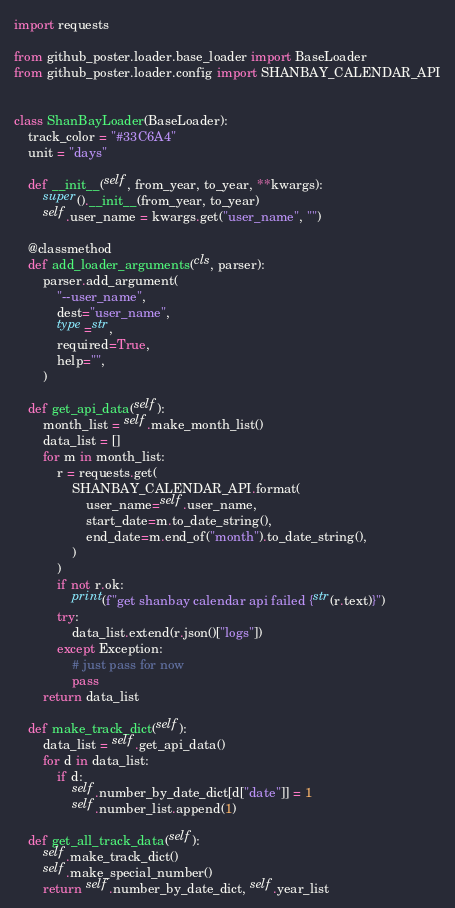<code> <loc_0><loc_0><loc_500><loc_500><_Python_>import requests

from github_poster.loader.base_loader import BaseLoader
from github_poster.loader.config import SHANBAY_CALENDAR_API


class ShanBayLoader(BaseLoader):
    track_color = "#33C6A4"
    unit = "days"

    def __init__(self, from_year, to_year, **kwargs):
        super().__init__(from_year, to_year)
        self.user_name = kwargs.get("user_name", "")

    @classmethod
    def add_loader_arguments(cls, parser):
        parser.add_argument(
            "--user_name",
            dest="user_name",
            type=str,
            required=True,
            help="",
        )

    def get_api_data(self):
        month_list = self.make_month_list()
        data_list = []
        for m in month_list:
            r = requests.get(
                SHANBAY_CALENDAR_API.format(
                    user_name=self.user_name,
                    start_date=m.to_date_string(),
                    end_date=m.end_of("month").to_date_string(),
                )
            )
            if not r.ok:
                print(f"get shanbay calendar api failed {str(r.text)}")
            try:
                data_list.extend(r.json()["logs"])
            except Exception:
                # just pass for now
                pass
        return data_list

    def make_track_dict(self):
        data_list = self.get_api_data()
        for d in data_list:
            if d:
                self.number_by_date_dict[d["date"]] = 1
                self.number_list.append(1)

    def get_all_track_data(self):
        self.make_track_dict()
        self.make_special_number()
        return self.number_by_date_dict, self.year_list
</code> 